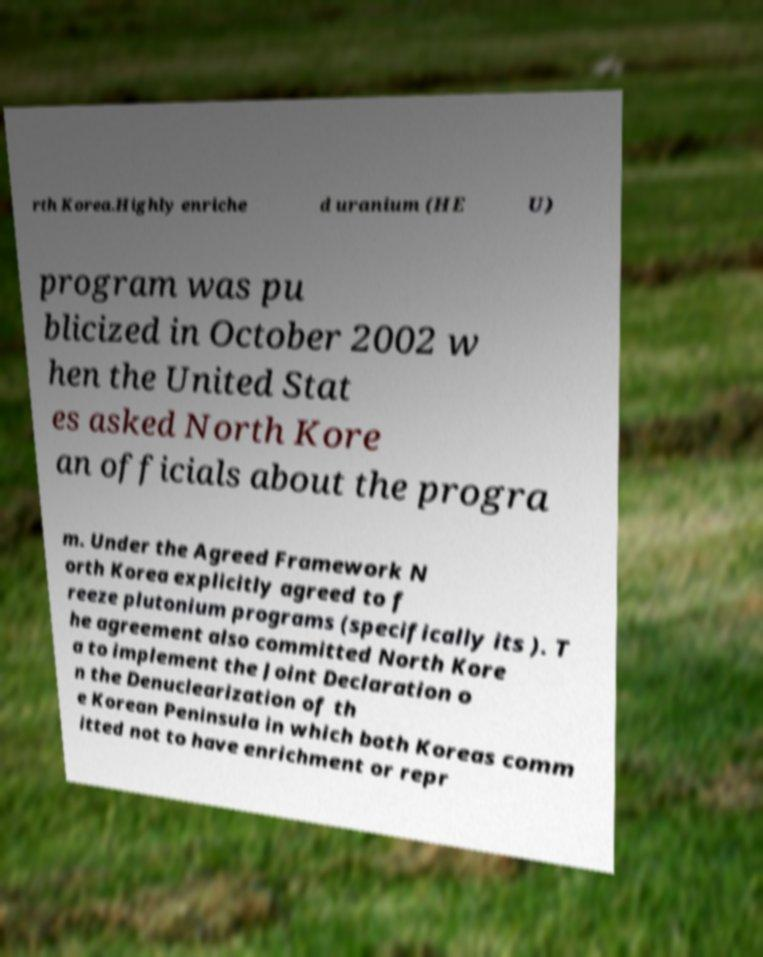There's text embedded in this image that I need extracted. Can you transcribe it verbatim? rth Korea.Highly enriche d uranium (HE U) program was pu blicized in October 2002 w hen the United Stat es asked North Kore an officials about the progra m. Under the Agreed Framework N orth Korea explicitly agreed to f reeze plutonium programs (specifically its ). T he agreement also committed North Kore a to implement the Joint Declaration o n the Denuclearization of th e Korean Peninsula in which both Koreas comm itted not to have enrichment or repr 